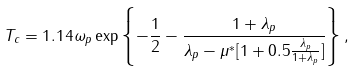<formula> <loc_0><loc_0><loc_500><loc_500>T _ { c } = 1 . 1 4 \omega _ { p } \exp \left \{ - \frac { 1 } { 2 } - \frac { 1 + \lambda _ { p } } { \lambda _ { p } - \mu ^ { \ast } [ 1 + 0 . 5 \frac { \lambda _ { p } } { 1 + \lambda _ { p } } ] } \right \} ,</formula> 